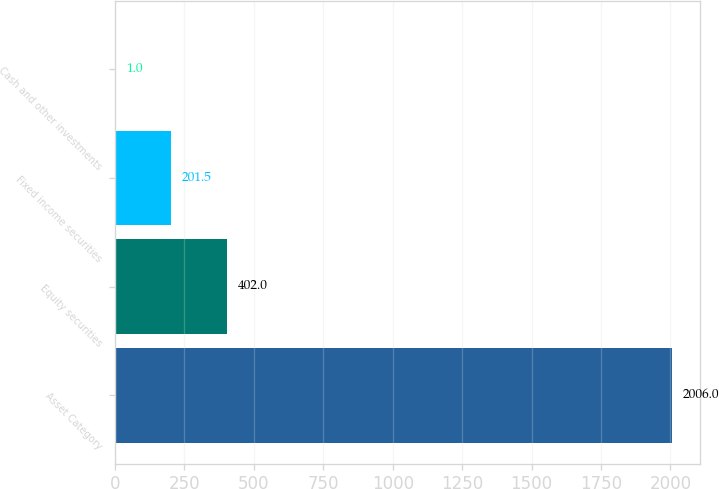Convert chart to OTSL. <chart><loc_0><loc_0><loc_500><loc_500><bar_chart><fcel>Asset Category<fcel>Equity securities<fcel>Fixed income securities<fcel>Cash and other investments<nl><fcel>2006<fcel>402<fcel>201.5<fcel>1<nl></chart> 